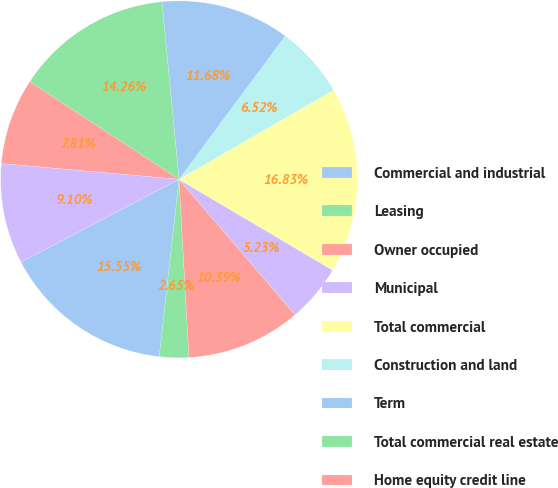Convert chart to OTSL. <chart><loc_0><loc_0><loc_500><loc_500><pie_chart><fcel>Commercial and industrial<fcel>Leasing<fcel>Owner occupied<fcel>Municipal<fcel>Total commercial<fcel>Construction and land<fcel>Term<fcel>Total commercial real estate<fcel>Home equity credit line<fcel>1-4 family residential<nl><fcel>15.55%<fcel>2.65%<fcel>10.39%<fcel>5.23%<fcel>16.84%<fcel>6.52%<fcel>11.68%<fcel>14.26%<fcel>7.81%<fcel>9.1%<nl></chart> 